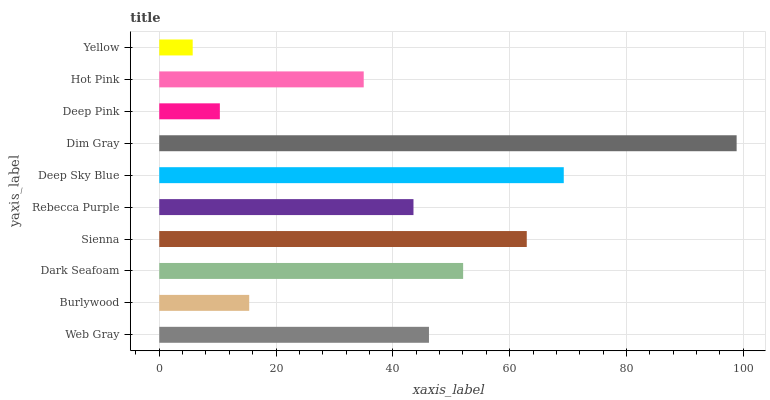Is Yellow the minimum?
Answer yes or no. Yes. Is Dim Gray the maximum?
Answer yes or no. Yes. Is Burlywood the minimum?
Answer yes or no. No. Is Burlywood the maximum?
Answer yes or no. No. Is Web Gray greater than Burlywood?
Answer yes or no. Yes. Is Burlywood less than Web Gray?
Answer yes or no. Yes. Is Burlywood greater than Web Gray?
Answer yes or no. No. Is Web Gray less than Burlywood?
Answer yes or no. No. Is Web Gray the high median?
Answer yes or no. Yes. Is Rebecca Purple the low median?
Answer yes or no. Yes. Is Deep Pink the high median?
Answer yes or no. No. Is Dim Gray the low median?
Answer yes or no. No. 